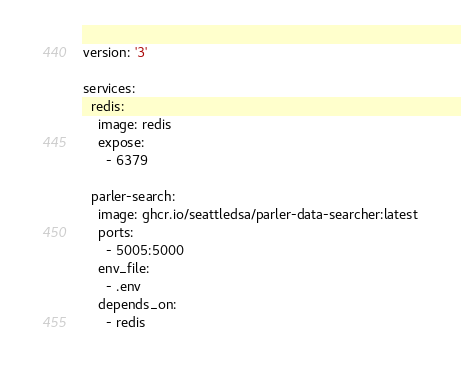Convert code to text. <code><loc_0><loc_0><loc_500><loc_500><_YAML_>version: '3'

services:
  redis:
    image: redis
    expose:
      - 6379

  parler-search:
    image: ghcr.io/seattledsa/parler-data-searcher:latest
    ports:
      - 5005:5000
    env_file:
      - .env
    depends_on:
      - redis
</code> 